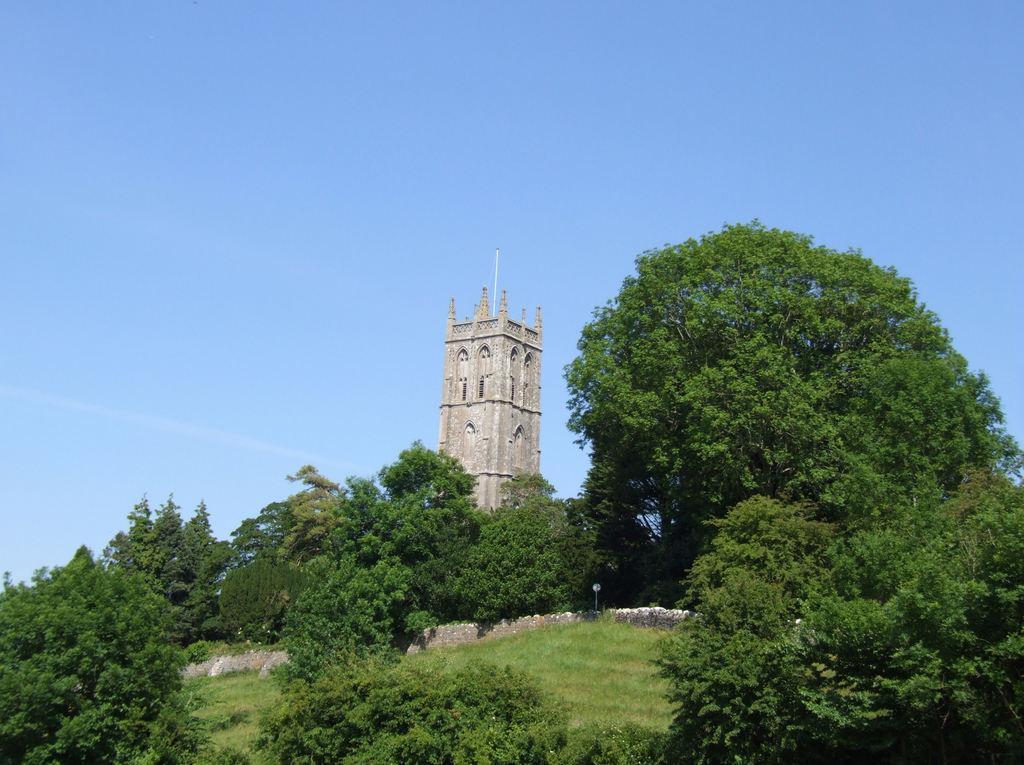In one or two sentences, can you explain what this image depicts? In this image I can see grass and number of trees in the front. In the background I can see a building and the sky. 